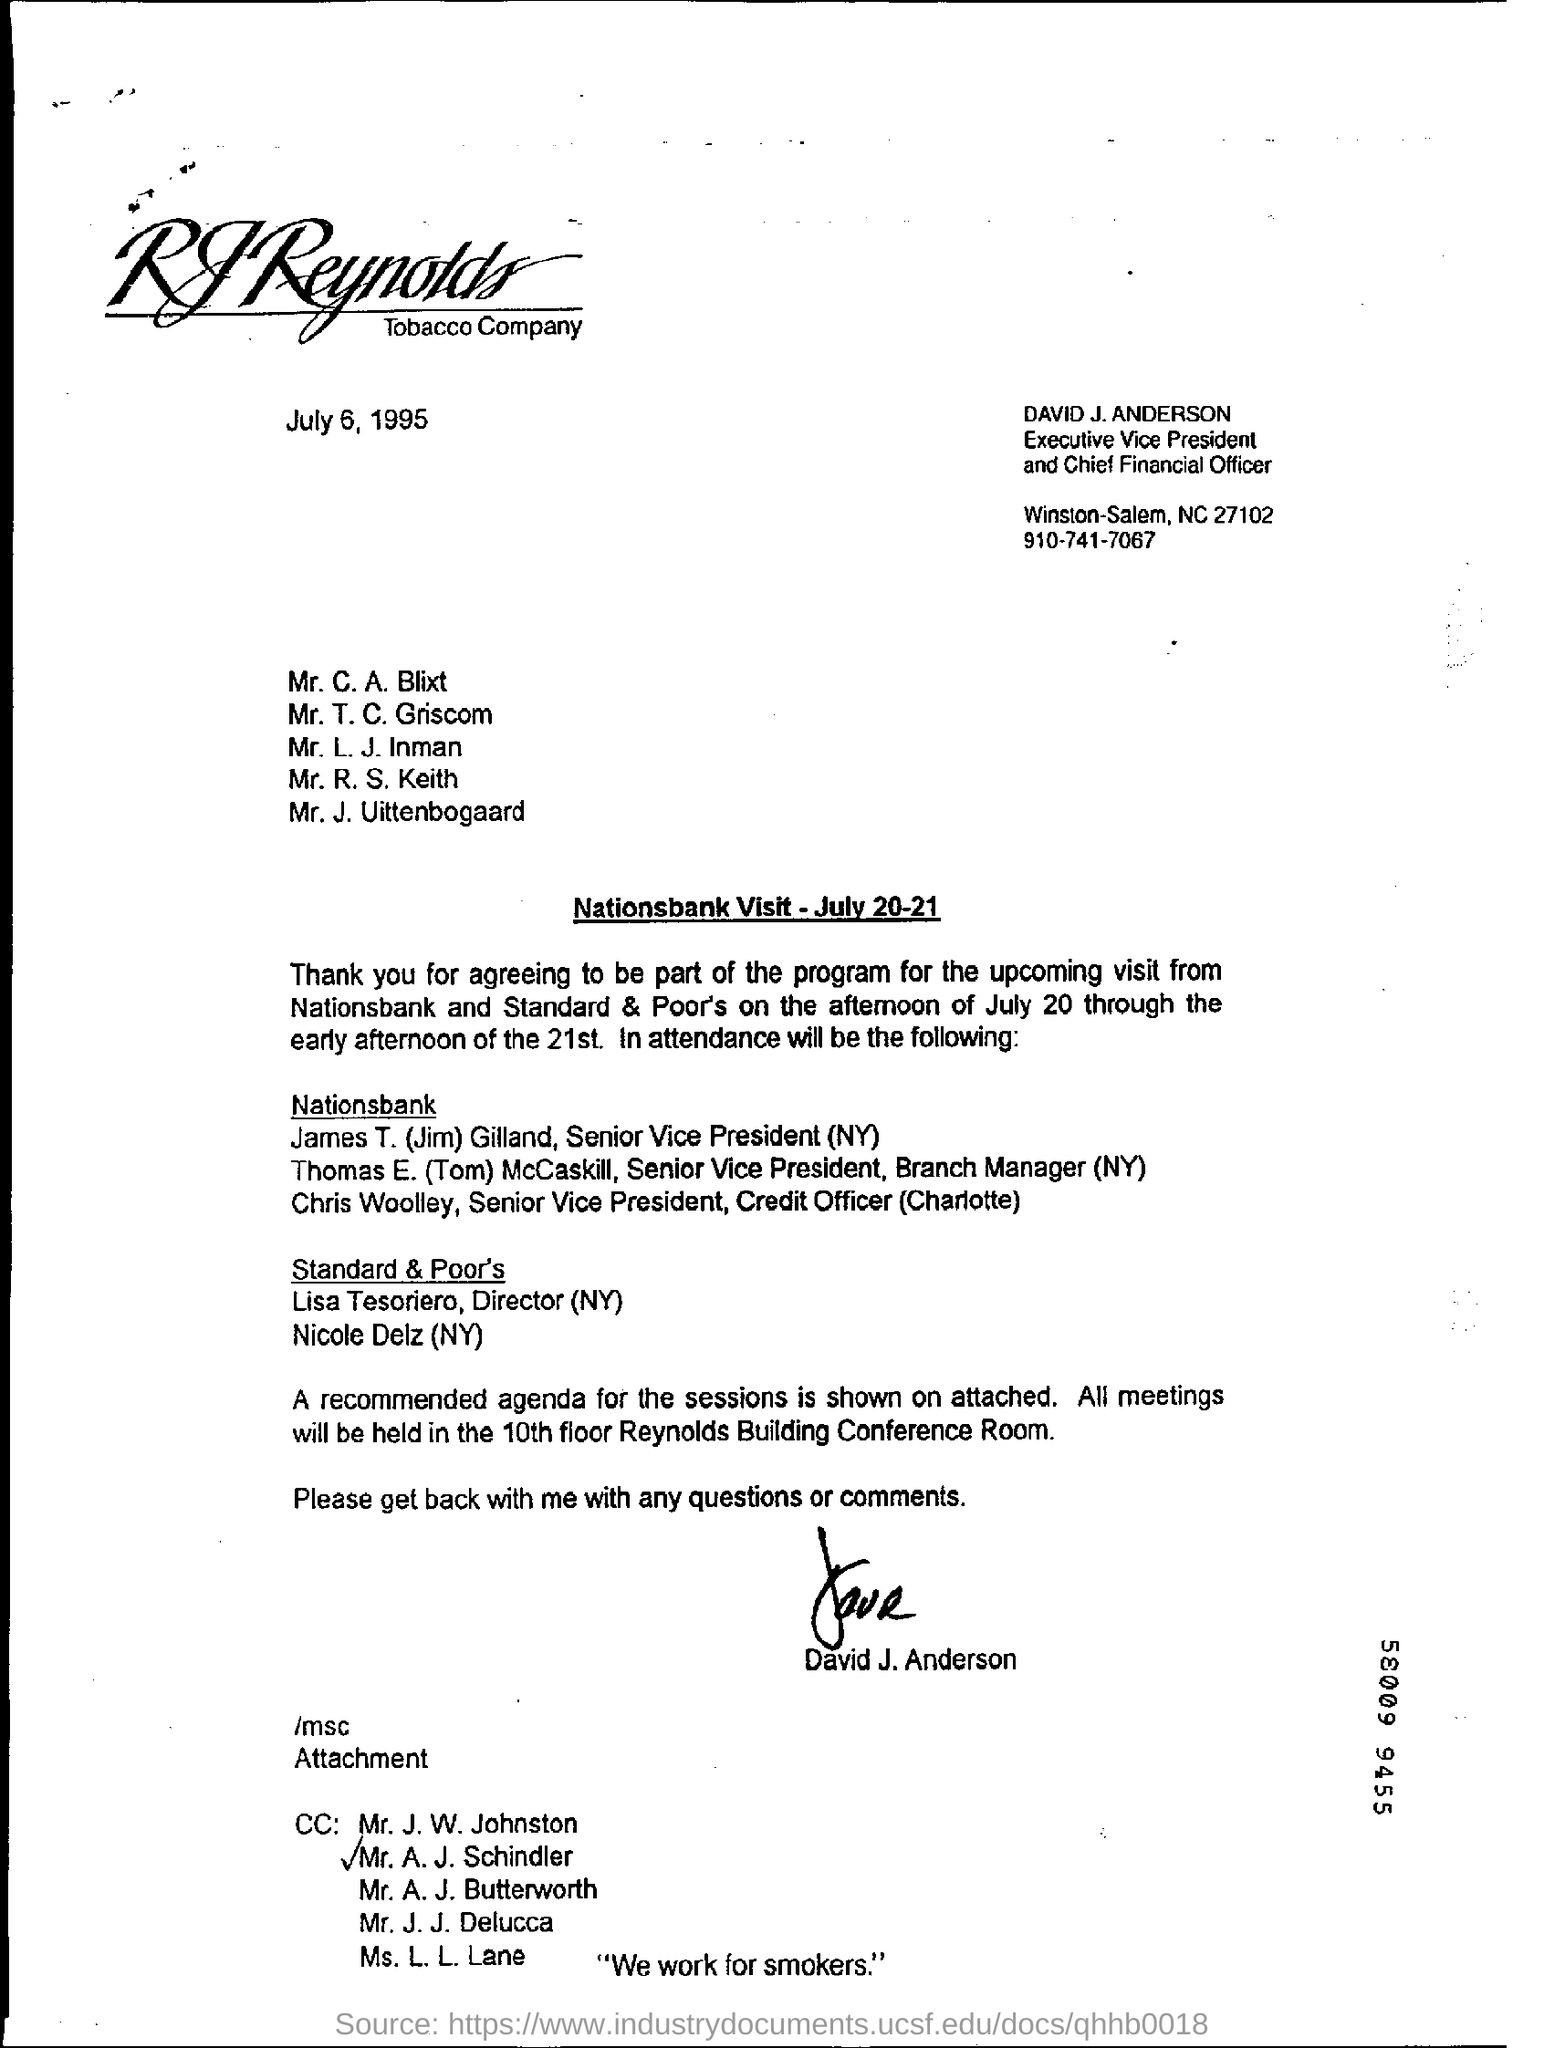Identify some key points in this picture. The issued date of this document is July 6, 1995. The individual named Jim Gilland is the Senior Vice President of Nationsbank located in New York. David J. Anderson is the Executive Vice President and Chief Financial Officer. The meetings are held in the 10th floor Reynolds Building Conference Room. 